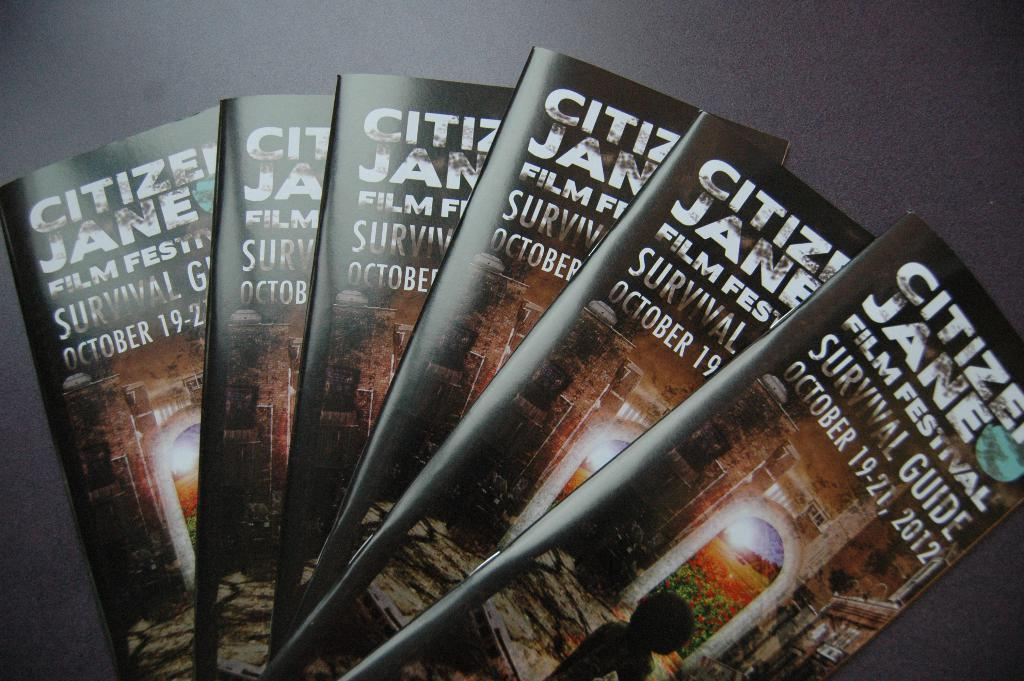How many books are visible in the image? There are six books in the image. What is the object on which the books are placed? The books are on an object, but the specific type of object is not mentioned in the facts. Is the woman in the image serving the books to the servant? There is no woman or servant present in the image, so this scenario cannot be observed. 